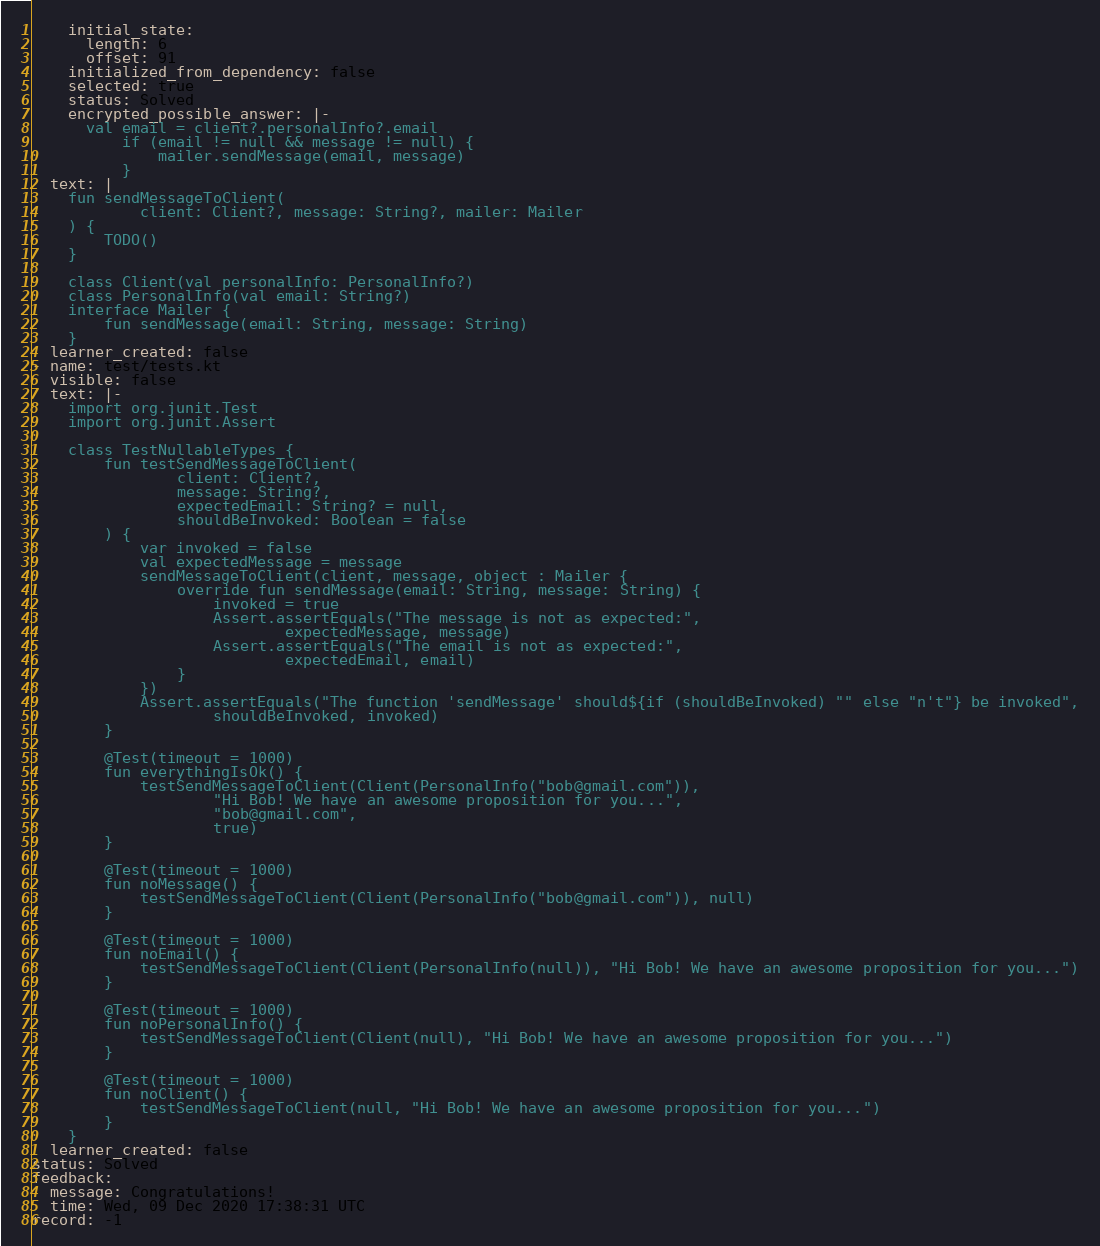<code> <loc_0><loc_0><loc_500><loc_500><_YAML_>    initial_state:
      length: 6
      offset: 91
    initialized_from_dependency: false
    selected: true
    status: Solved
    encrypted_possible_answer: |-
      val email = client?.personalInfo?.email
          if (email != null && message != null) {
              mailer.sendMessage(email, message)
          }
  text: |
    fun sendMessageToClient(
            client: Client?, message: String?, mailer: Mailer
    ) {
        TODO()
    }

    class Client(val personalInfo: PersonalInfo?)
    class PersonalInfo(val email: String?)
    interface Mailer {
        fun sendMessage(email: String, message: String)
    }
  learner_created: false
- name: test/tests.kt
  visible: false
  text: |-
    import org.junit.Test
    import org.junit.Assert

    class TestNullableTypes {
        fun testSendMessageToClient(
                client: Client?,
                message: String?,
                expectedEmail: String? = null,
                shouldBeInvoked: Boolean = false
        ) {
            var invoked = false
            val expectedMessage = message
            sendMessageToClient(client, message, object : Mailer {
                override fun sendMessage(email: String, message: String) {
                    invoked = true
                    Assert.assertEquals("The message is not as expected:",
                            expectedMessage, message)
                    Assert.assertEquals("The email is not as expected:",
                            expectedEmail, email)
                }
            })
            Assert.assertEquals("The function 'sendMessage' should${if (shouldBeInvoked) "" else "n't"} be invoked",
                    shouldBeInvoked, invoked)
        }

        @Test(timeout = 1000)
        fun everythingIsOk() {
            testSendMessageToClient(Client(PersonalInfo("bob@gmail.com")),
                    "Hi Bob! We have an awesome proposition for you...",
                    "bob@gmail.com",
                    true)
        }

        @Test(timeout = 1000)
        fun noMessage() {
            testSendMessageToClient(Client(PersonalInfo("bob@gmail.com")), null)
        }

        @Test(timeout = 1000)
        fun noEmail() {
            testSendMessageToClient(Client(PersonalInfo(null)), "Hi Bob! We have an awesome proposition for you...")
        }

        @Test(timeout = 1000)
        fun noPersonalInfo() {
            testSendMessageToClient(Client(null), "Hi Bob! We have an awesome proposition for you...")
        }

        @Test(timeout = 1000)
        fun noClient() {
            testSendMessageToClient(null, "Hi Bob! We have an awesome proposition for you...")
        }
    }
  learner_created: false
status: Solved
feedback:
  message: Congratulations!
  time: Wed, 09 Dec 2020 17:38:31 UTC
record: -1
</code> 